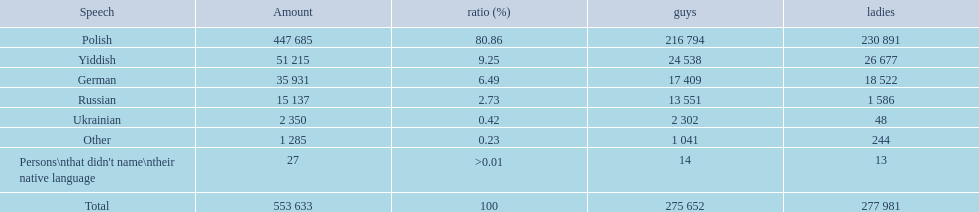What are all of the languages? Polish, Yiddish, German, Russian, Ukrainian, Other, Persons\nthat didn't name\ntheir native language. And how many people speak these languages? 447 685, 51 215, 35 931, 15 137, 2 350, 1 285, 27. Which language is used by most people? Polish. 